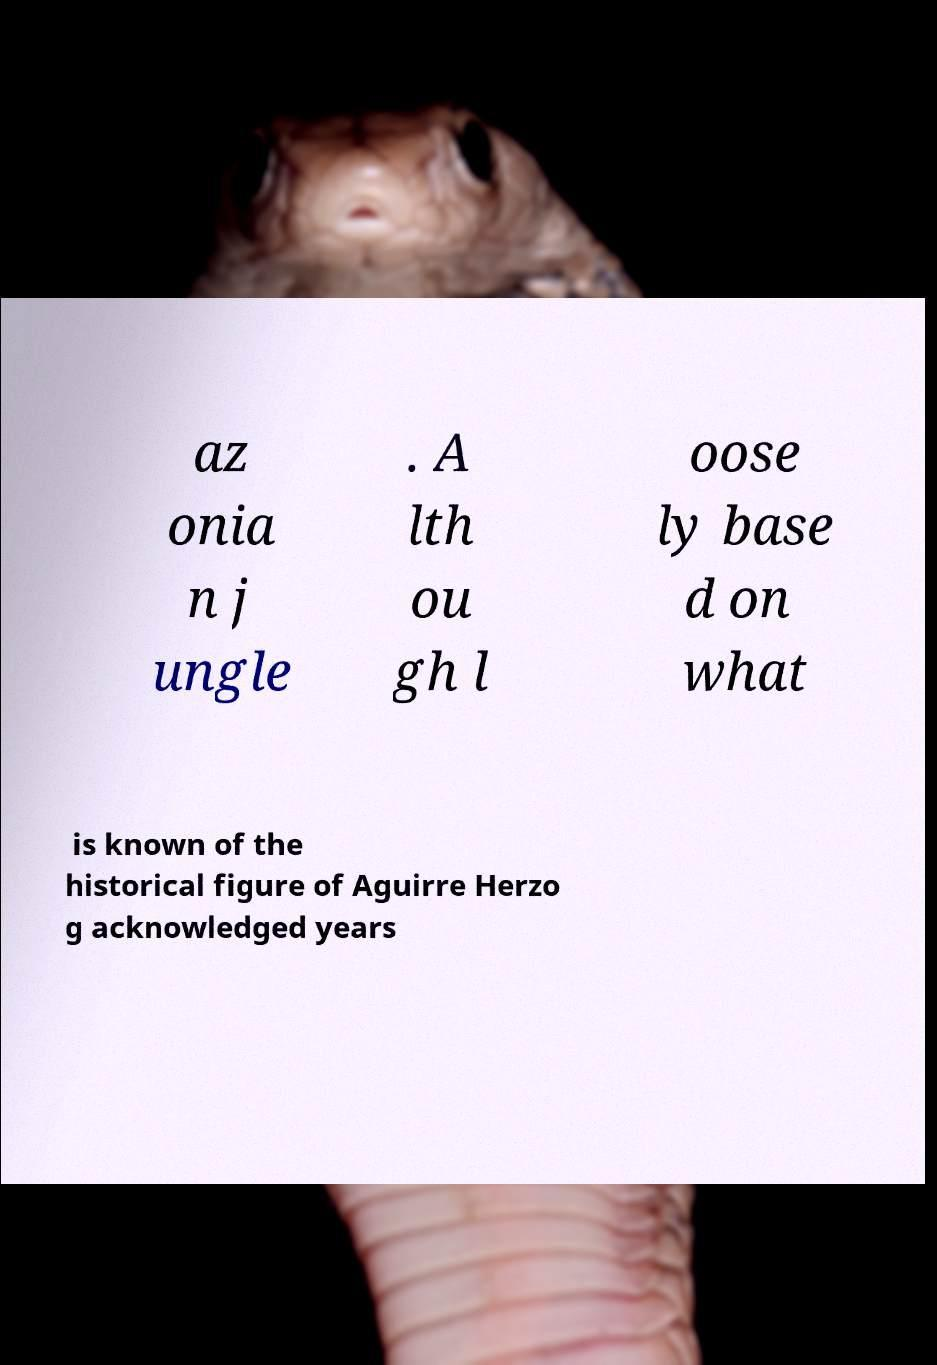Could you extract and type out the text from this image? az onia n j ungle . A lth ou gh l oose ly base d on what is known of the historical figure of Aguirre Herzo g acknowledged years 